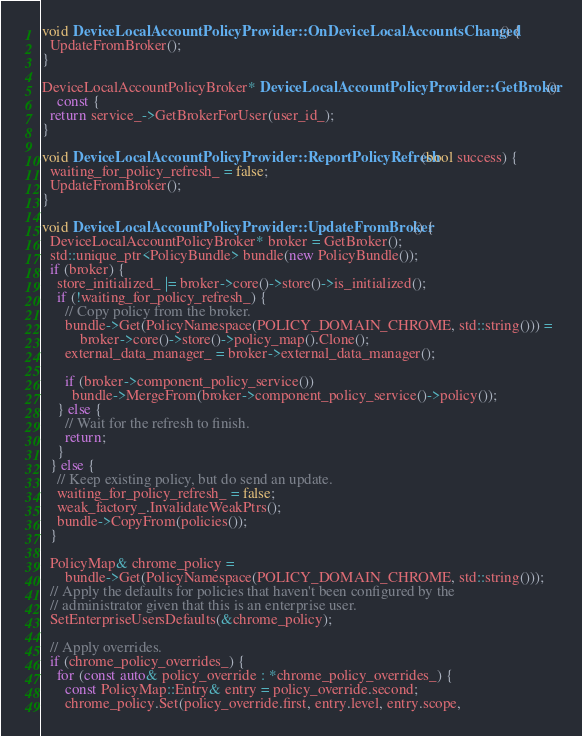Convert code to text. <code><loc_0><loc_0><loc_500><loc_500><_C++_>void DeviceLocalAccountPolicyProvider::OnDeviceLocalAccountsChanged() {
  UpdateFromBroker();
}

DeviceLocalAccountPolicyBroker* DeviceLocalAccountPolicyProvider::GetBroker()
    const {
  return service_->GetBrokerForUser(user_id_);
}

void DeviceLocalAccountPolicyProvider::ReportPolicyRefresh(bool success) {
  waiting_for_policy_refresh_ = false;
  UpdateFromBroker();
}

void DeviceLocalAccountPolicyProvider::UpdateFromBroker() {
  DeviceLocalAccountPolicyBroker* broker = GetBroker();
  std::unique_ptr<PolicyBundle> bundle(new PolicyBundle());
  if (broker) {
    store_initialized_ |= broker->core()->store()->is_initialized();
    if (!waiting_for_policy_refresh_) {
      // Copy policy from the broker.
      bundle->Get(PolicyNamespace(POLICY_DOMAIN_CHROME, std::string())) =
          broker->core()->store()->policy_map().Clone();
      external_data_manager_ = broker->external_data_manager();

      if (broker->component_policy_service())
        bundle->MergeFrom(broker->component_policy_service()->policy());
    } else {
      // Wait for the refresh to finish.
      return;
    }
  } else {
    // Keep existing policy, but do send an update.
    waiting_for_policy_refresh_ = false;
    weak_factory_.InvalidateWeakPtrs();
    bundle->CopyFrom(policies());
  }

  PolicyMap& chrome_policy =
      bundle->Get(PolicyNamespace(POLICY_DOMAIN_CHROME, std::string()));
  // Apply the defaults for policies that haven't been configured by the
  // administrator given that this is an enterprise user.
  SetEnterpriseUsersDefaults(&chrome_policy);

  // Apply overrides.
  if (chrome_policy_overrides_) {
    for (const auto& policy_override : *chrome_policy_overrides_) {
      const PolicyMap::Entry& entry = policy_override.second;
      chrome_policy.Set(policy_override.first, entry.level, entry.scope,</code> 